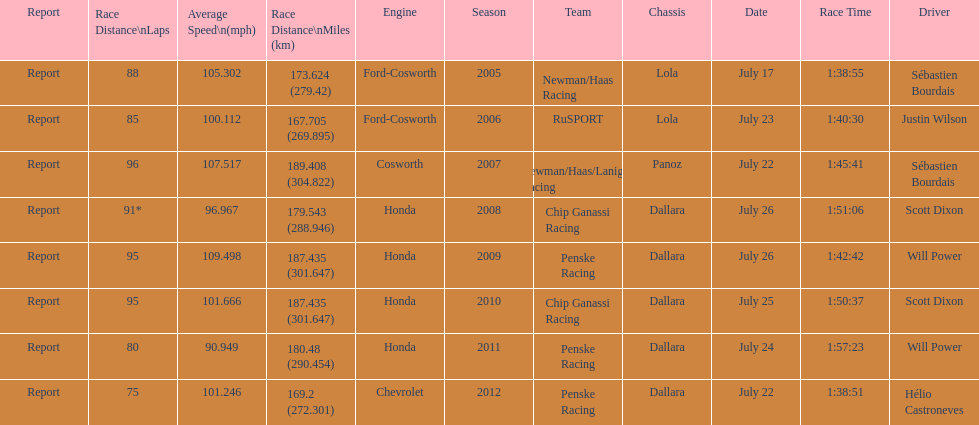How many total honda engines were there? 4. 